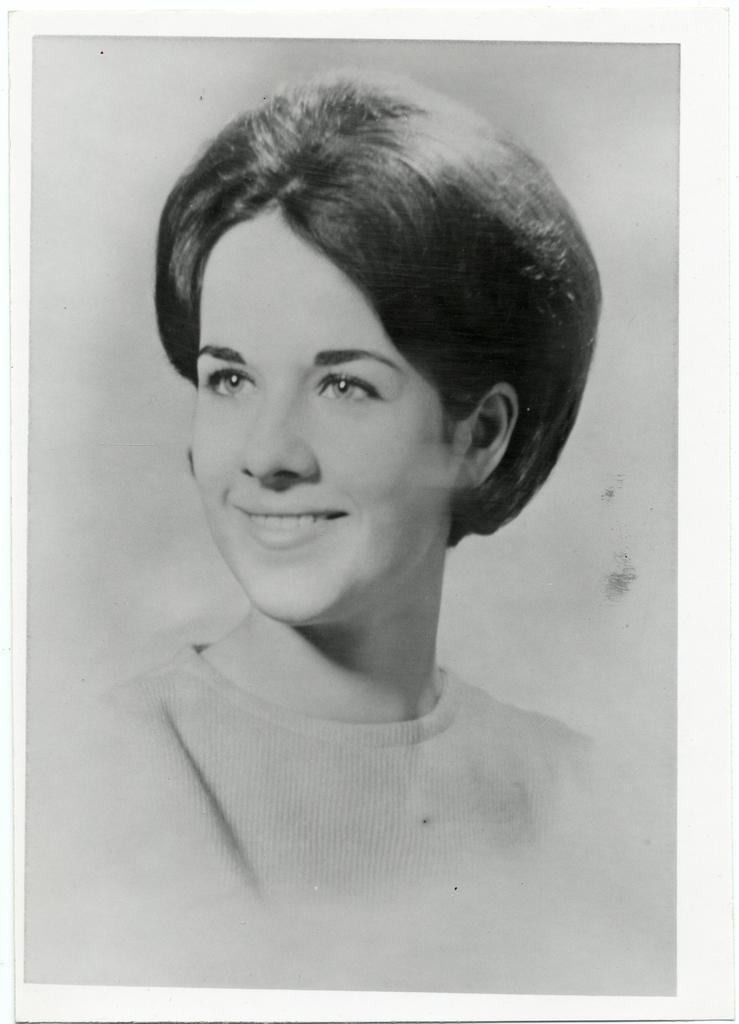Can you describe this image briefly? In this picture we can see a black and white photograph, in the photograph we can find a woman, she is smiling. 